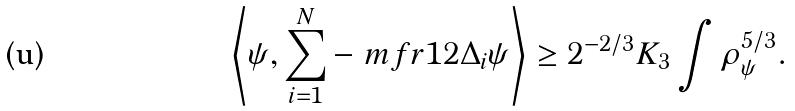<formula> <loc_0><loc_0><loc_500><loc_500>\left \langle \psi , \sum _ { i = 1 } ^ { N } - \ m f r { 1 } { 2 } \Delta _ { i } \psi \right \rangle \geq 2 ^ { - 2 / 3 } K _ { 3 } \int \rho _ { \psi } ^ { 5 / 3 } .</formula> 